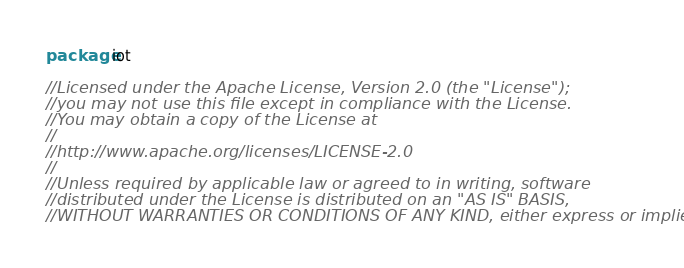<code> <loc_0><loc_0><loc_500><loc_500><_Go_>package iot

//Licensed under the Apache License, Version 2.0 (the "License");
//you may not use this file except in compliance with the License.
//You may obtain a copy of the License at
//
//http://www.apache.org/licenses/LICENSE-2.0
//
//Unless required by applicable law or agreed to in writing, software
//distributed under the License is distributed on an "AS IS" BASIS,
//WITHOUT WARRANTIES OR CONDITIONS OF ANY KIND, either express or implied.</code> 